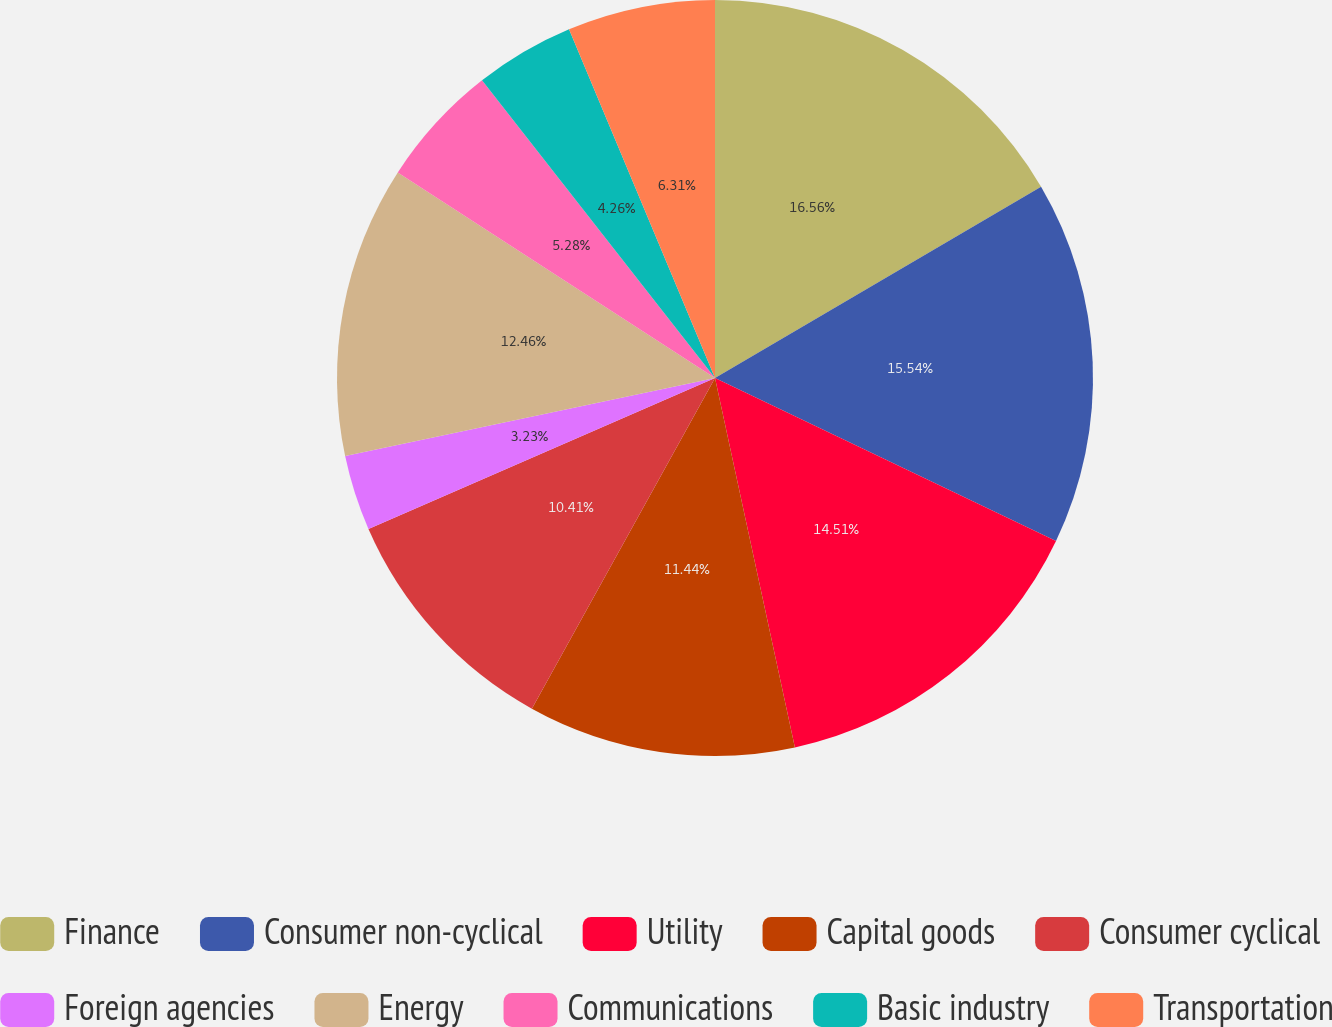Convert chart to OTSL. <chart><loc_0><loc_0><loc_500><loc_500><pie_chart><fcel>Finance<fcel>Consumer non-cyclical<fcel>Utility<fcel>Capital goods<fcel>Consumer cyclical<fcel>Foreign agencies<fcel>Energy<fcel>Communications<fcel>Basic industry<fcel>Transportation<nl><fcel>16.56%<fcel>15.54%<fcel>14.51%<fcel>11.44%<fcel>10.41%<fcel>3.23%<fcel>12.46%<fcel>5.28%<fcel>4.26%<fcel>6.31%<nl></chart> 